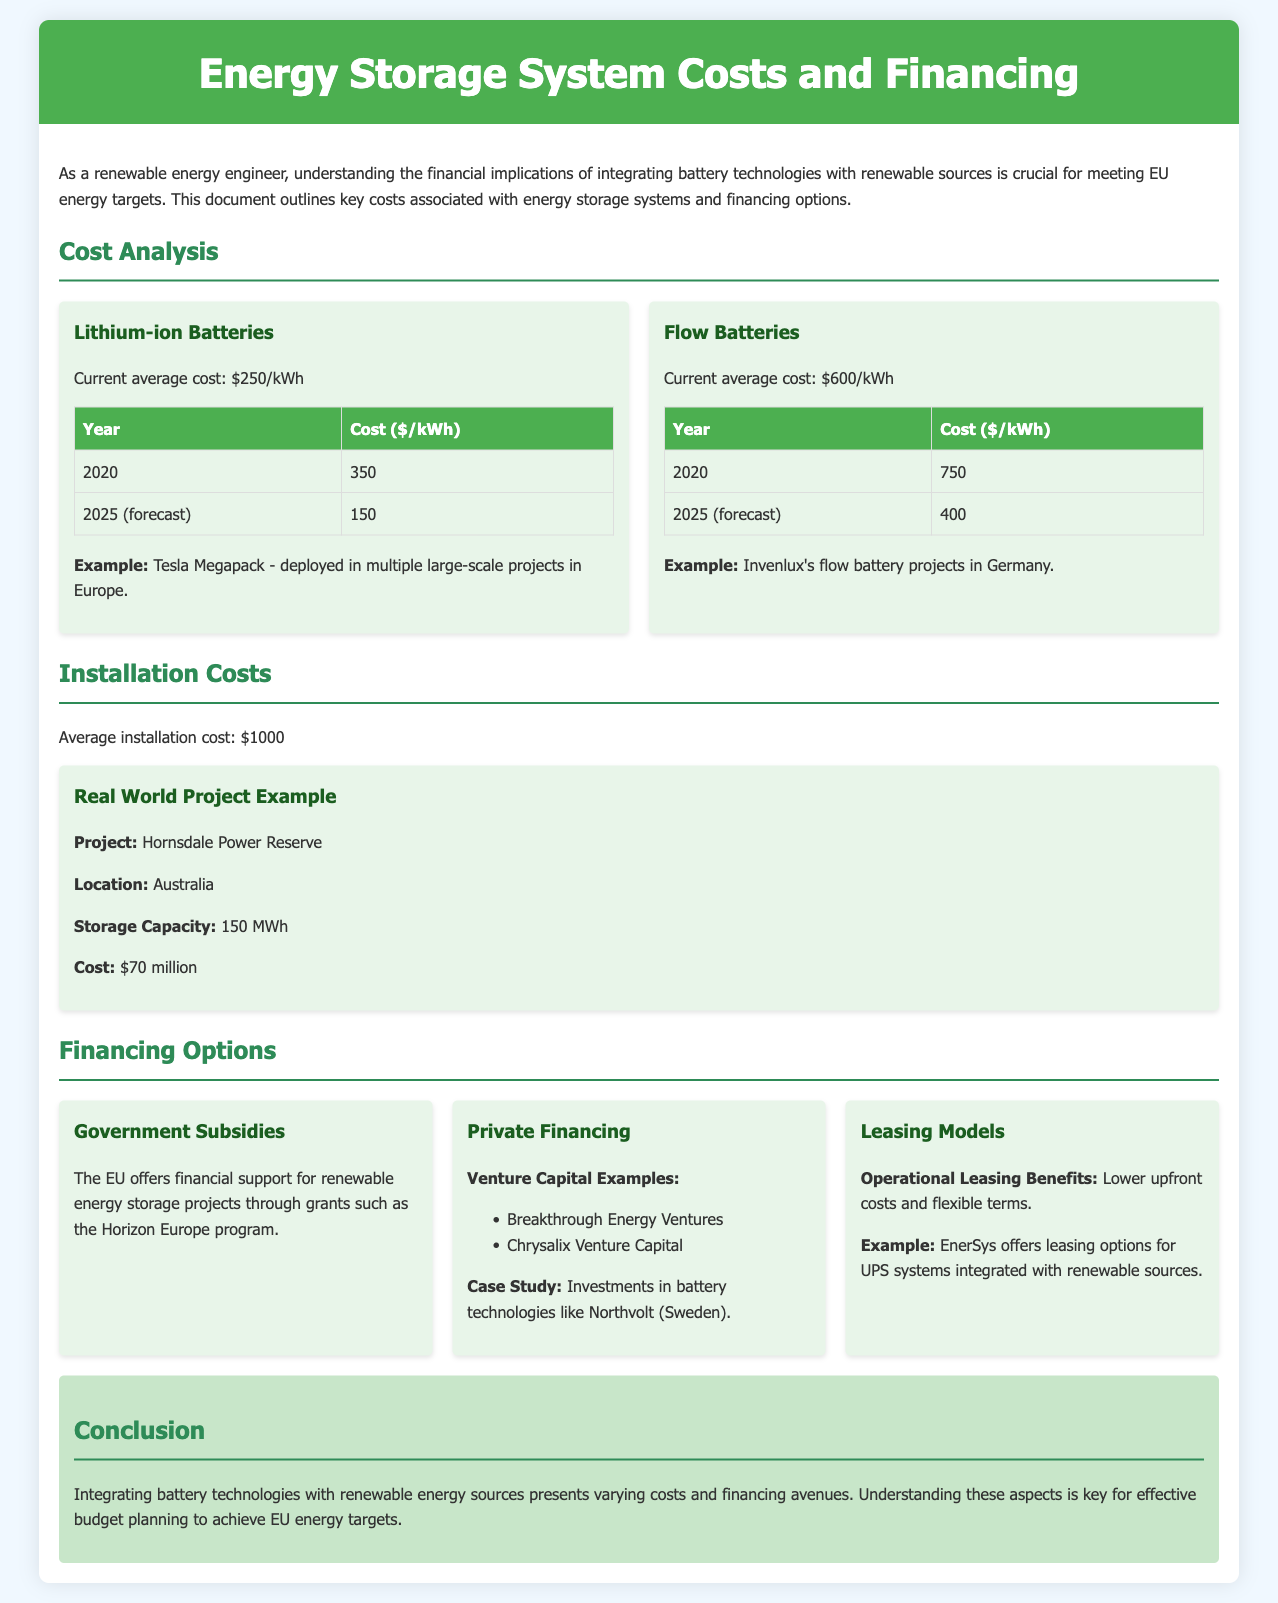What is the current average cost of lithium-ion batteries? The current average cost of lithium-ion batteries is stated directly in the document.
Answer: $250/kWh What is the cost forecast for flow batteries in 2025? The cost forecast for flow batteries in 2025 is explicitly noted.
Answer: $400 What was the installation cost mentioned in the document? The document provides a specific average installation cost for energy storage systems.
Answer: $1000 What project is used as a real-world example? The document names a specific project used to illustrate installation costs.
Answer: Hornsdale Power Reserve Which financing option is provided by the EU? The document lists a specific financing option available from the EU for renewable energy projects.
Answer: Government Subsidies What is the storage capacity of the Hornsdale Power Reserve project? The storage capacity is stated explicitly in the project section of the document.
Answer: 150 MWh What are the venture capital examples mentioned for private financing? The document lists specific examples of venture capital firms related to battery technologies.
Answer: Breakthrough Energy Ventures, Chrysalix Venture Capital What are the benefits of operational leasing mentioned? The document lists advantages of operational leasing as part of financing options.
Answer: Lower upfront costs and flexible terms What is the average cost of batteries in 2020? The document provides the average costs of batteries for both lithium-ion and flow batteries for the year 2020.
Answer: $350/$750 